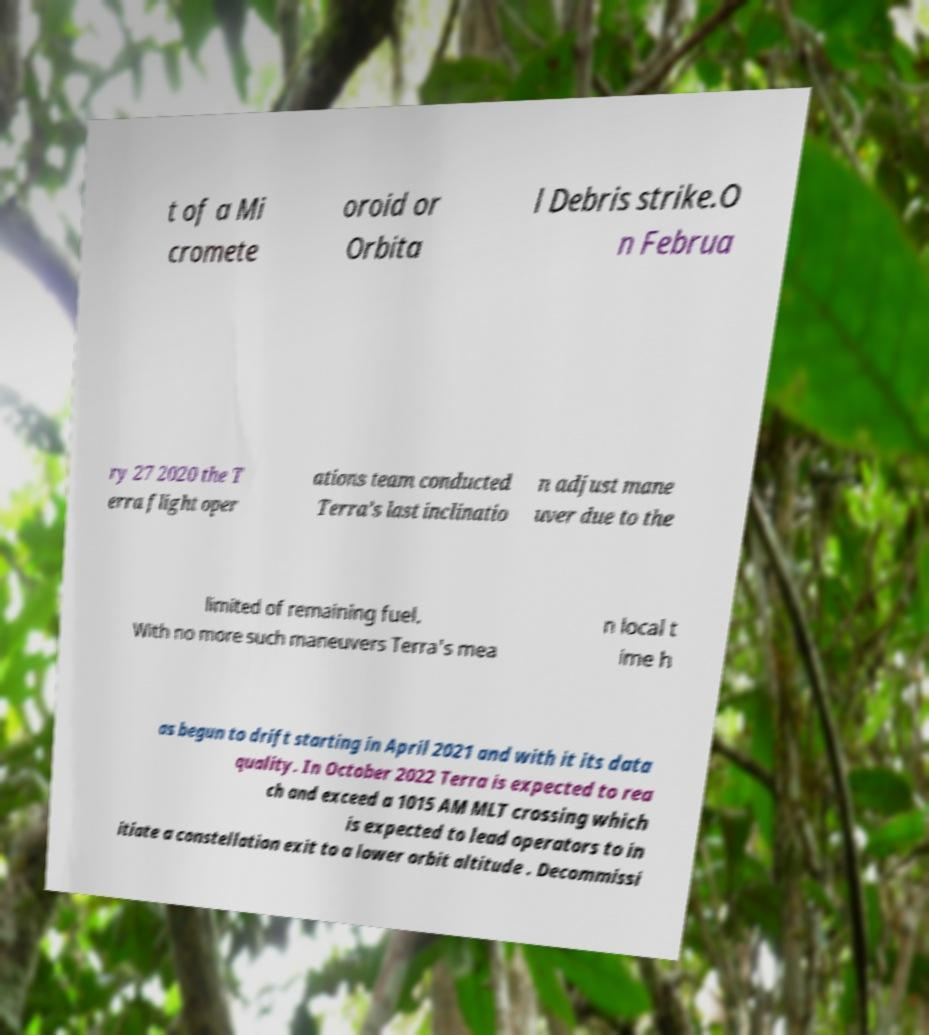I need the written content from this picture converted into text. Can you do that? t of a Mi cromete oroid or Orbita l Debris strike.O n Februa ry 27 2020 the T erra flight oper ations team conducted Terra’s last inclinatio n adjust mane uver due to the limited of remaining fuel. With no more such maneuvers Terra's mea n local t ime h as begun to drift starting in April 2021 and with it its data quality. In October 2022 Terra is expected to rea ch and exceed a 1015 AM MLT crossing which is expected to lead operators to in itiate a constellation exit to a lower orbit altitude . Decommissi 